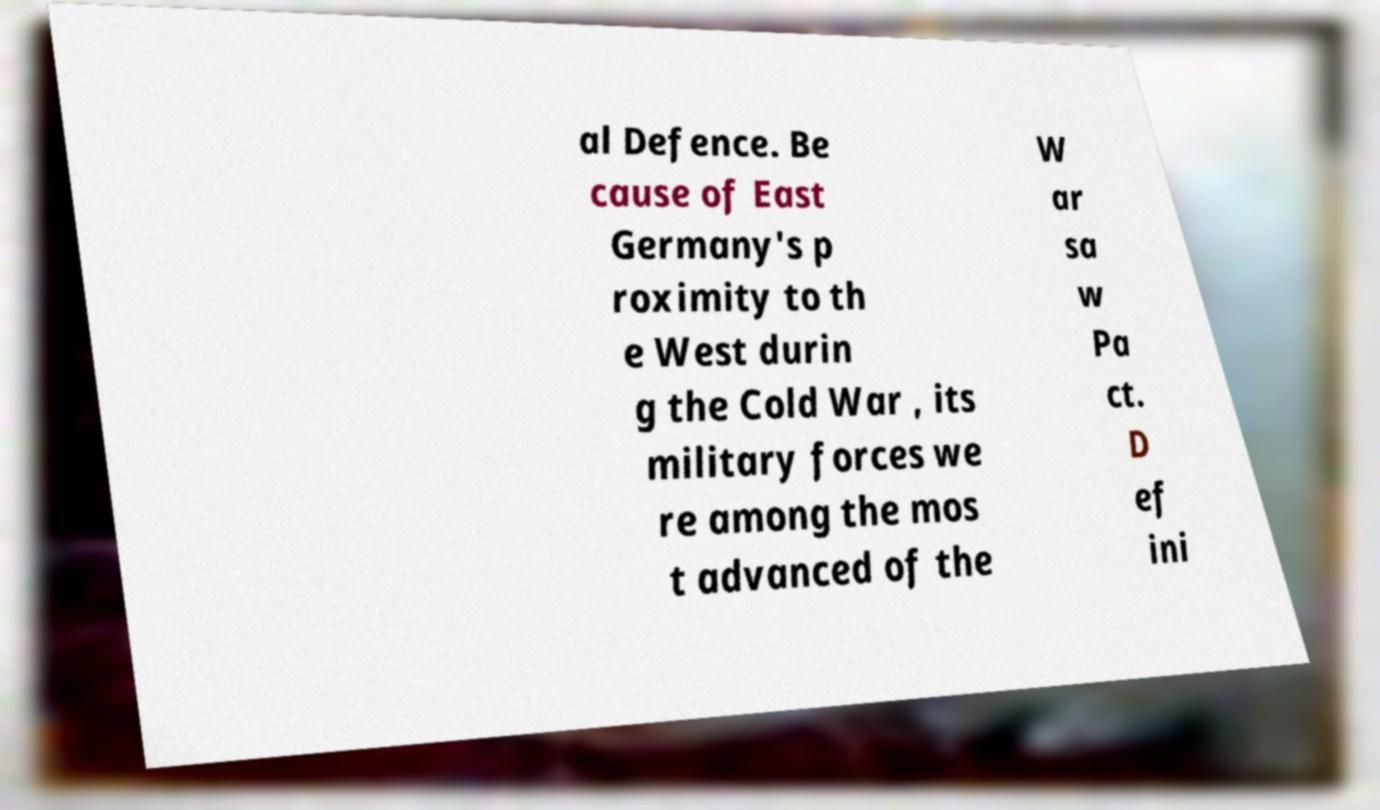For documentation purposes, I need the text within this image transcribed. Could you provide that? al Defence. Be cause of East Germany's p roximity to th e West durin g the Cold War , its military forces we re among the mos t advanced of the W ar sa w Pa ct. D ef ini 